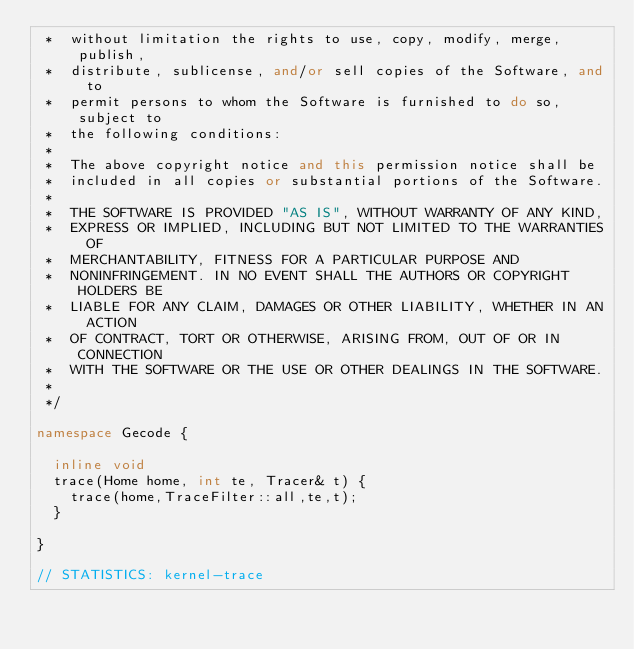<code> <loc_0><loc_0><loc_500><loc_500><_C++_> *  without limitation the rights to use, copy, modify, merge, publish,
 *  distribute, sublicense, and/or sell copies of the Software, and to
 *  permit persons to whom the Software is furnished to do so, subject to
 *  the following conditions:
 *
 *  The above copyright notice and this permission notice shall be
 *  included in all copies or substantial portions of the Software.
 *
 *  THE SOFTWARE IS PROVIDED "AS IS", WITHOUT WARRANTY OF ANY KIND,
 *  EXPRESS OR IMPLIED, INCLUDING BUT NOT LIMITED TO THE WARRANTIES OF
 *  MERCHANTABILITY, FITNESS FOR A PARTICULAR PURPOSE AND
 *  NONINFRINGEMENT. IN NO EVENT SHALL THE AUTHORS OR COPYRIGHT HOLDERS BE
 *  LIABLE FOR ANY CLAIM, DAMAGES OR OTHER LIABILITY, WHETHER IN AN ACTION
 *  OF CONTRACT, TORT OR OTHERWISE, ARISING FROM, OUT OF OR IN CONNECTION
 *  WITH THE SOFTWARE OR THE USE OR OTHER DEALINGS IN THE SOFTWARE.
 *
 */

namespace Gecode {

  inline void
  trace(Home home, int te, Tracer& t) {
    trace(home,TraceFilter::all,te,t);
  }

}

// STATISTICS: kernel-trace
</code> 